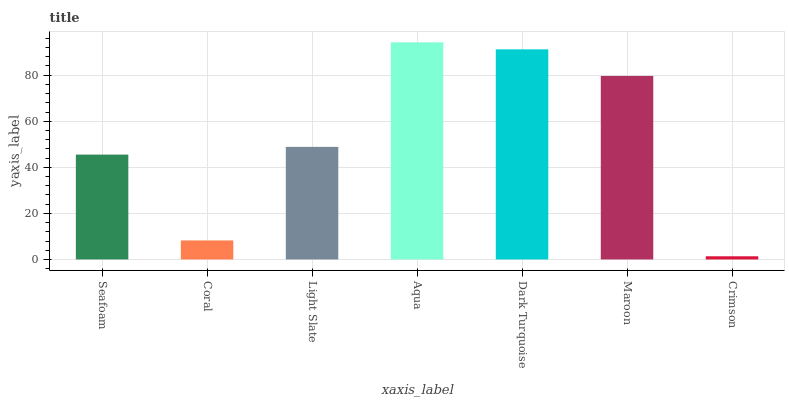Is Coral the minimum?
Answer yes or no. No. Is Coral the maximum?
Answer yes or no. No. Is Seafoam greater than Coral?
Answer yes or no. Yes. Is Coral less than Seafoam?
Answer yes or no. Yes. Is Coral greater than Seafoam?
Answer yes or no. No. Is Seafoam less than Coral?
Answer yes or no. No. Is Light Slate the high median?
Answer yes or no. Yes. Is Light Slate the low median?
Answer yes or no. Yes. Is Coral the high median?
Answer yes or no. No. Is Aqua the low median?
Answer yes or no. No. 